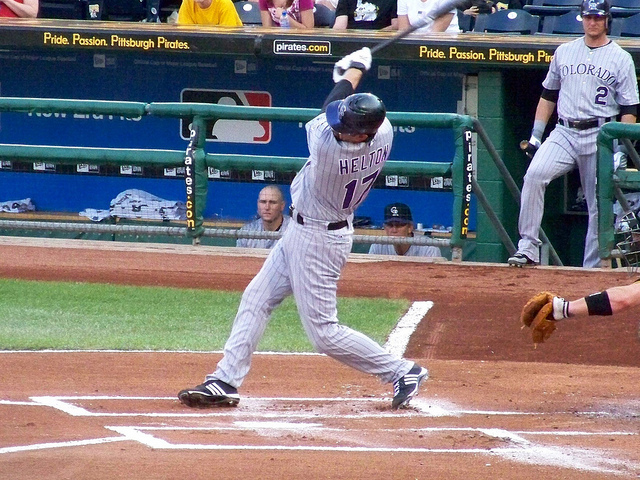Read all the text in this image. Pride. Passion Pittsburgh Pirates pirates.com Pirates.com 17 HELTON 2 Pire Pittsburgh Passion Pride 